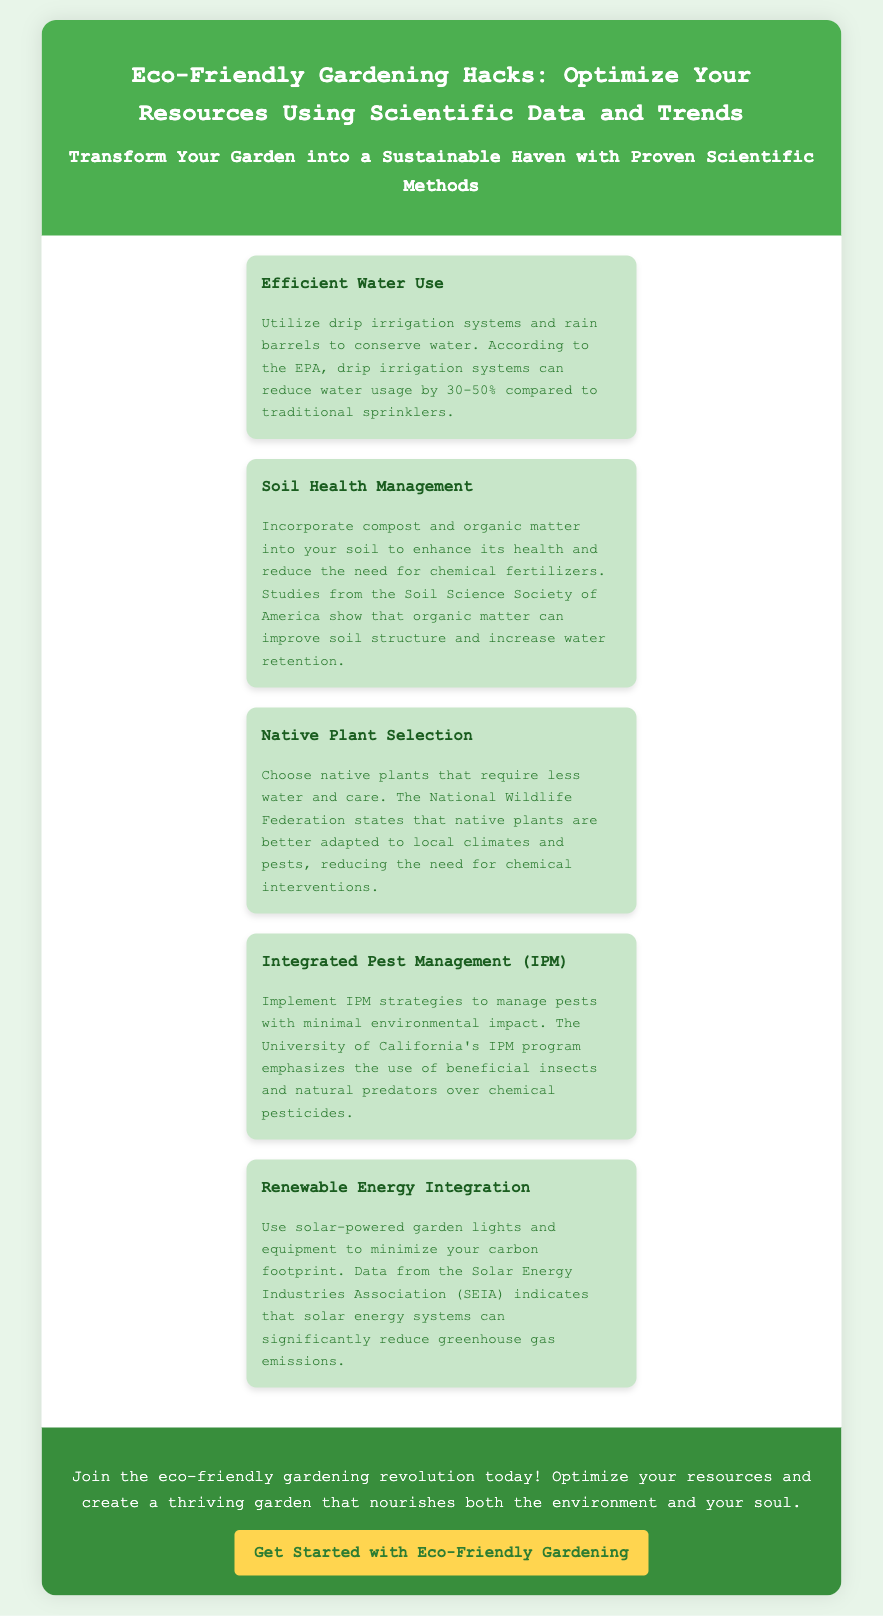What is the title of the advertisement? The title is presented in the header section of the document.
Answer: Eco-Friendly Gardening Hacks: Optimize Your Resources Using Scientific Data and Trends What is one method to conserve water mentioned? The document lists efficient water use strategies in the benefits section.
Answer: Drip irrigation systems What percentage can drip irrigation reduce water usage? This statistic is directly mentioned within the description of efficient water use.
Answer: 30-50% Who states that native plants are better adapted to local climates? The authority on the information regarding native plants is cited in the document.
Answer: National Wildlife Federation What does IPM stand for? This is mentioned in the context of pest management strategies throughout the document.
Answer: Integrated Pest Management According to the document, what is one benefit of using compost? The benefit is described under soil health management.
Answer: Enhances soil health What do solar-powered systems help to minimize? This claim is made in the renewable energy integration section of the advertisement.
Answer: Carbon footprint What is the call to action in the advertisement? The document provides a specific phrase as a call to action.
Answer: Get Started with Eco-Friendly Gardening 